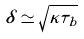Convert formula to latex. <formula><loc_0><loc_0><loc_500><loc_500>\delta \simeq \sqrt { \kappa \tau _ { b } }</formula> 